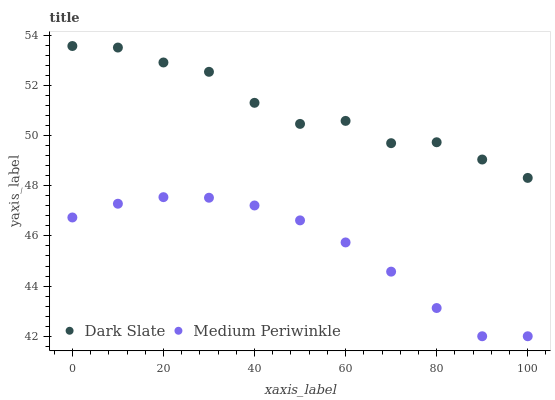Does Medium Periwinkle have the minimum area under the curve?
Answer yes or no. Yes. Does Dark Slate have the maximum area under the curve?
Answer yes or no. Yes. Does Medium Periwinkle have the maximum area under the curve?
Answer yes or no. No. Is Medium Periwinkle the smoothest?
Answer yes or no. Yes. Is Dark Slate the roughest?
Answer yes or no. Yes. Is Medium Periwinkle the roughest?
Answer yes or no. No. Does Medium Periwinkle have the lowest value?
Answer yes or no. Yes. Does Dark Slate have the highest value?
Answer yes or no. Yes. Does Medium Periwinkle have the highest value?
Answer yes or no. No. Is Medium Periwinkle less than Dark Slate?
Answer yes or no. Yes. Is Dark Slate greater than Medium Periwinkle?
Answer yes or no. Yes. Does Medium Periwinkle intersect Dark Slate?
Answer yes or no. No. 